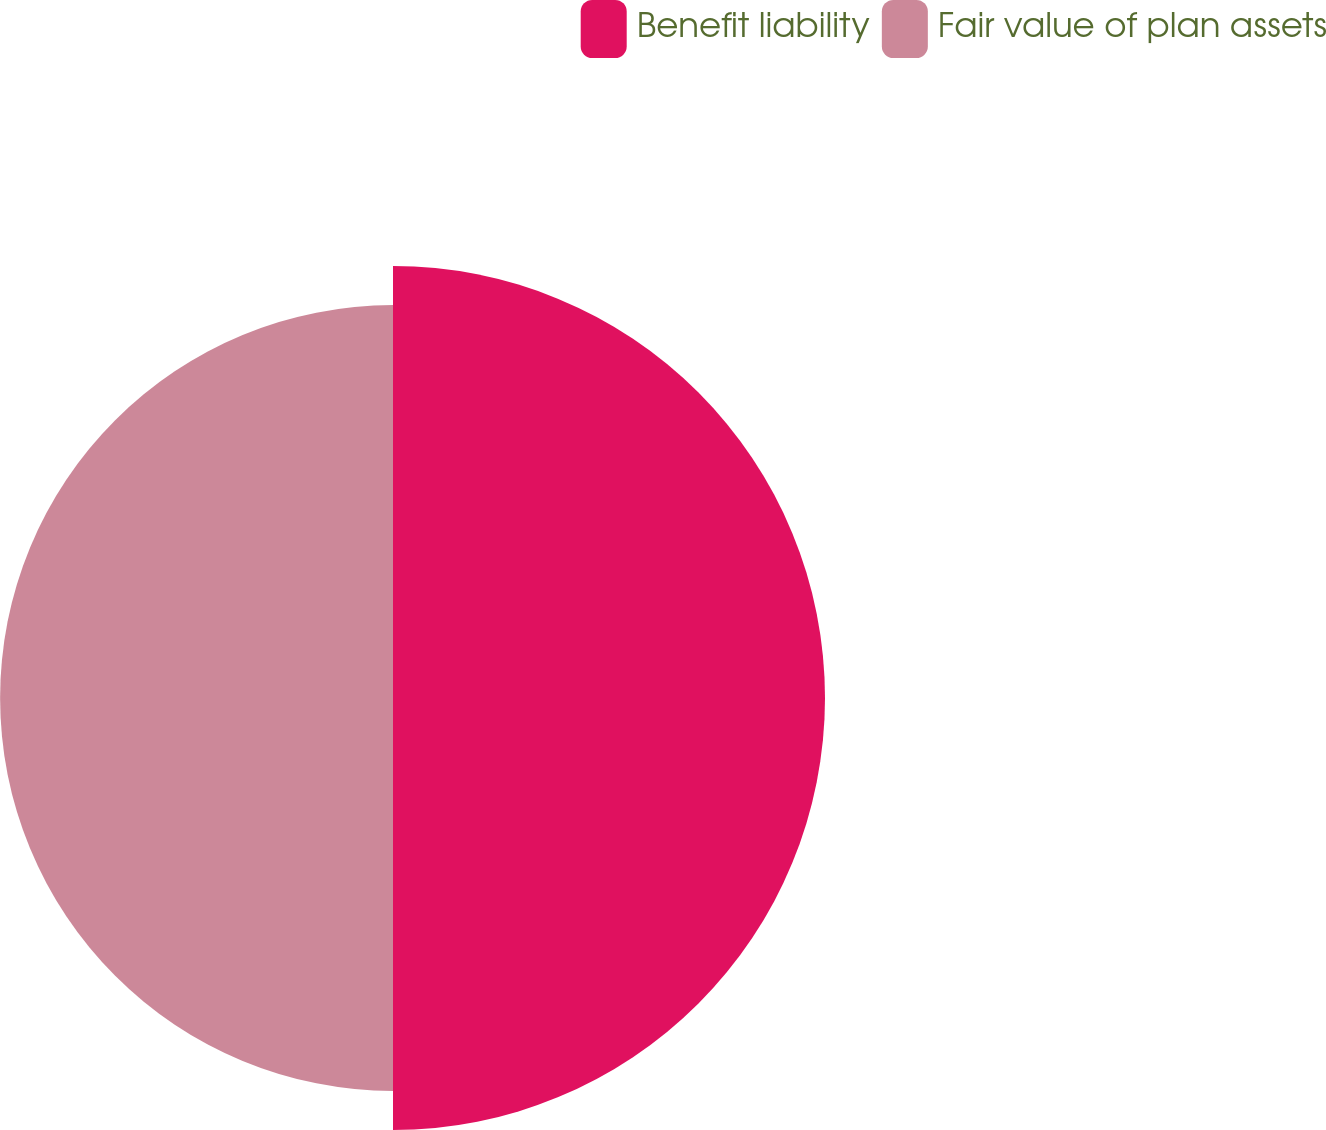Convert chart. <chart><loc_0><loc_0><loc_500><loc_500><pie_chart><fcel>Benefit liability<fcel>Fair value of plan assets<nl><fcel>52.37%<fcel>47.63%<nl></chart> 